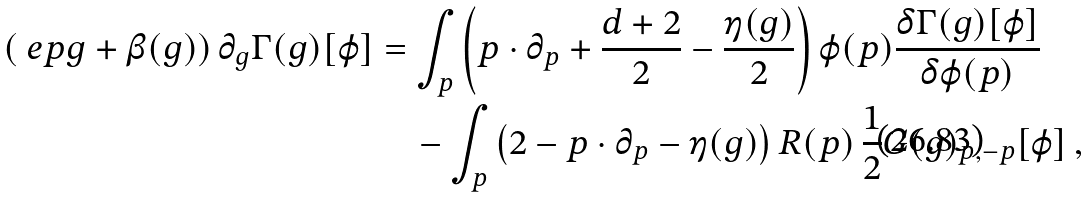Convert formula to latex. <formula><loc_0><loc_0><loc_500><loc_500>\left ( \ e p g + \beta ( g ) \right ) \partial _ { g } \Gamma ( g ) [ \varphi ] & = \int _ { p } \left ( p \cdot \partial _ { p } + \frac { d + 2 } { 2 } - \frac { \eta ( g ) } { 2 } \right ) \varphi ( p ) \frac { \delta \Gamma ( g ) [ \varphi ] } { \delta \varphi ( p ) } \\ & \quad - \int _ { p } \left ( 2 - p \cdot \partial _ { p } - \eta ( g ) \right ) R ( p ) \, \frac { 1 } { 2 } G ( g ) _ { p , - p } [ \varphi ] \, ,</formula> 